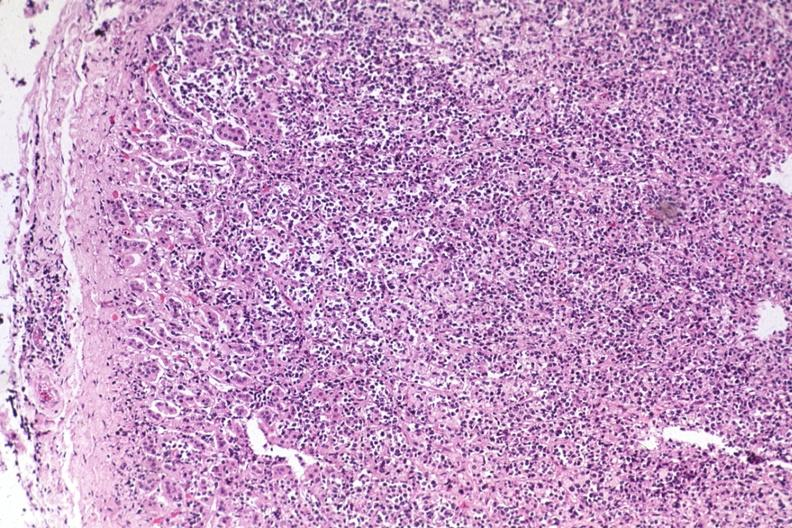s carcinoma present?
Answer the question using a single word or phrase. No 